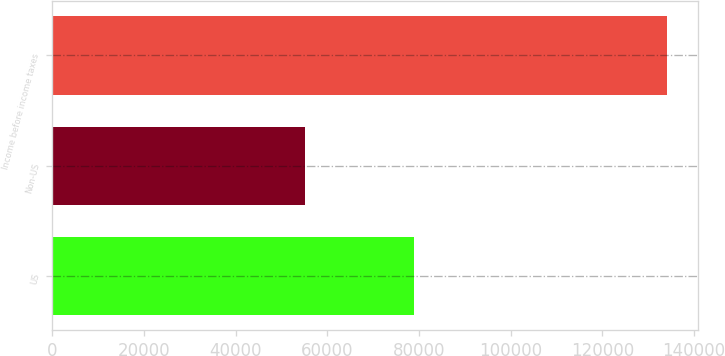<chart> <loc_0><loc_0><loc_500><loc_500><bar_chart><fcel>US<fcel>Non-US<fcel>Income before income taxes<nl><fcel>78933<fcel>55152<fcel>134085<nl></chart> 